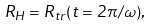<formula> <loc_0><loc_0><loc_500><loc_500>R _ { H } = R _ { t r } ( t = 2 \pi / \omega ) ,</formula> 